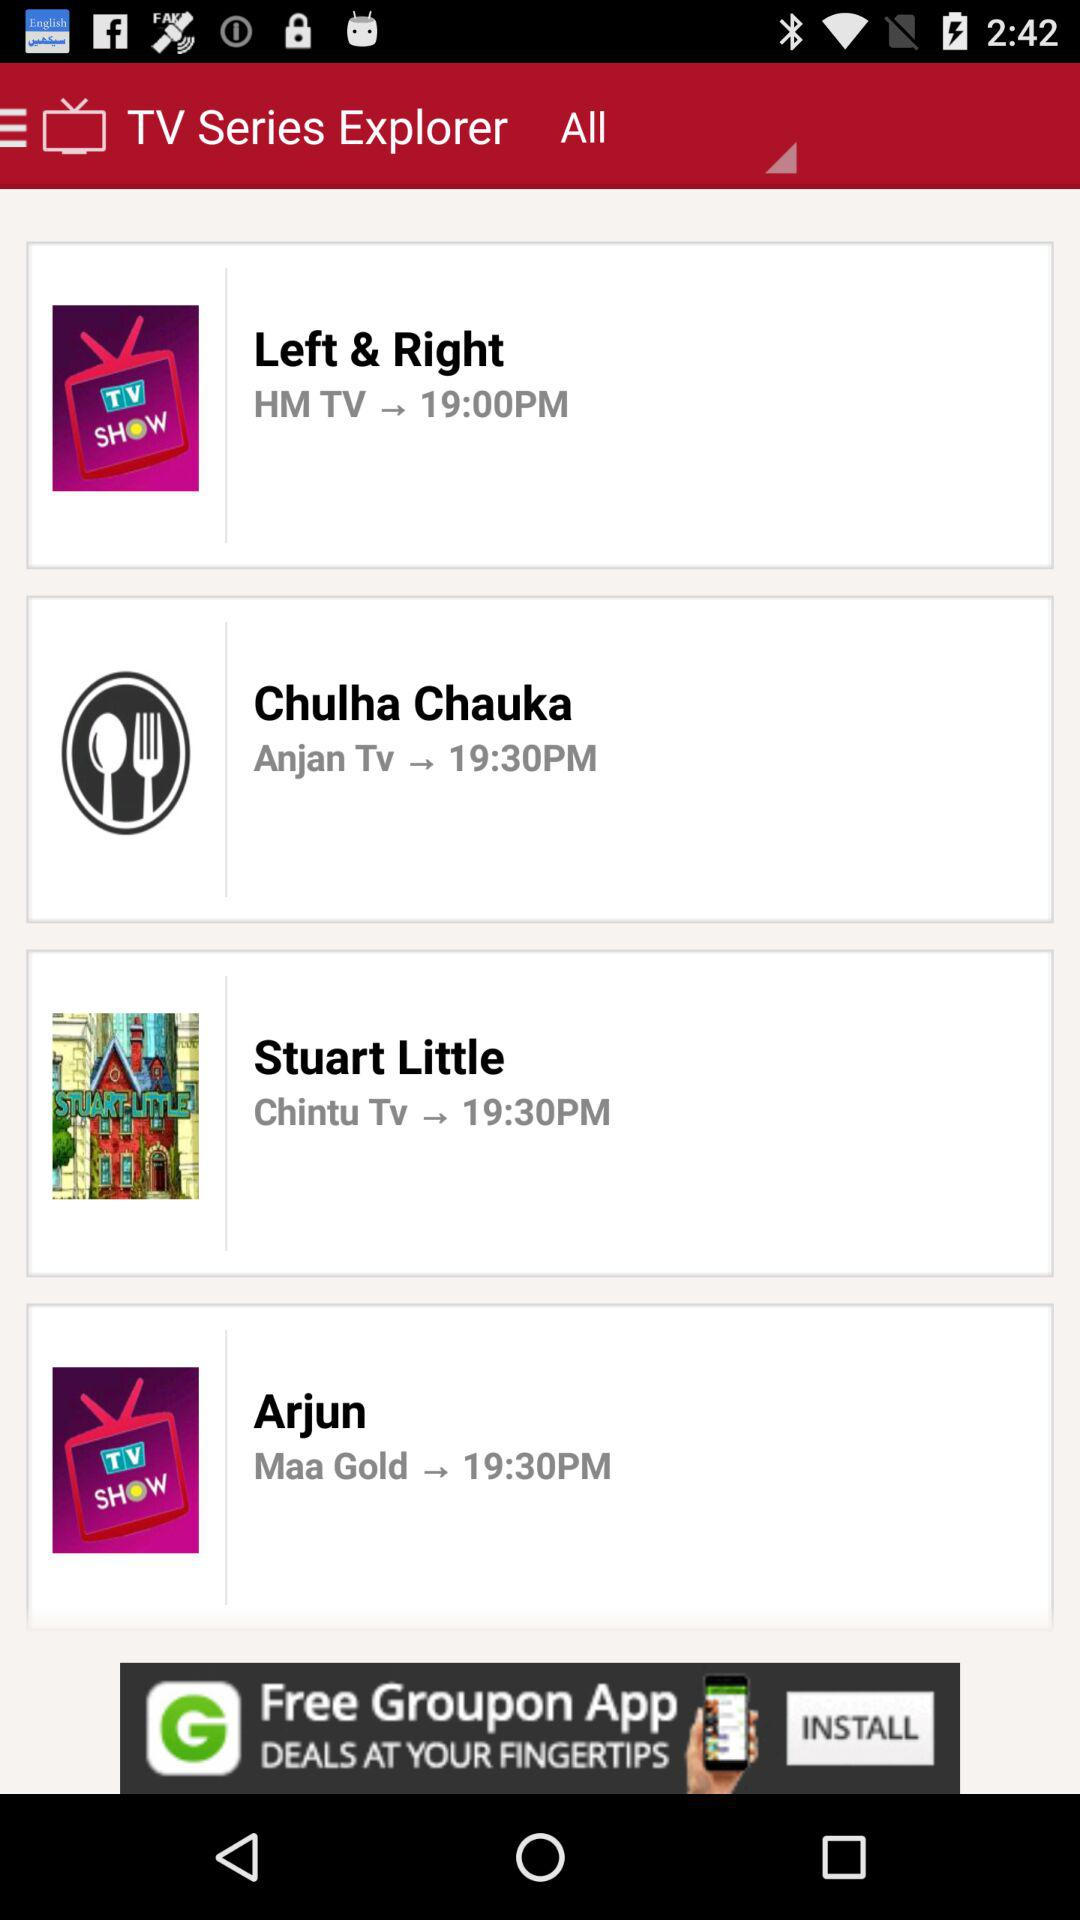On which channel is "Chulha Chauka" broadcast? The show "Chulha Chauka" is broadcast on "Anjan Tv". 